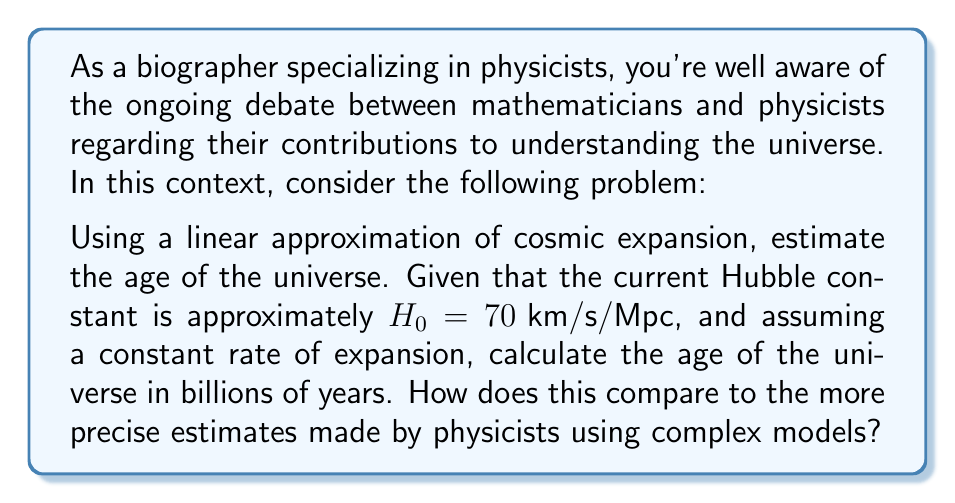Give your solution to this math problem. To solve this problem, we'll use a linear approximation of the Hubble-Lemaître law, which relates the recessional velocity of galaxies to their distance from Earth. This simplification allows us to estimate the age of the universe using basic mathematical concepts.

1. The Hubble-Lemaître law is given by:

   $v = H_0 \cdot d$

   where $v$ is the recessional velocity, $H_0$ is the Hubble constant, and $d$ is the distance.

2. If we assume a constant rate of expansion, we can use the simple relation:

   $\text{Time} = \frac{\text{Distance}}{\text{Velocity}}$

3. The age of the universe would be the time it takes for a galaxy to reach a distance of 1 from a starting point of 0, at the velocity given by the Hubble constant. Therefore:

   $\text{Age} = \frac{1}{H_0}$

4. Convert the Hubble constant to appropriate units:
   $H_0 = 70 \text{ km/s/Mpc} = 70 \frac{\text{km}}{\text{s} \cdot \text{Mpc}}$

   Convert this to $\text{s}^{-1}$:
   $70 \frac{\text{km}}{\text{s} \cdot \text{Mpc}} \cdot \frac{1 \text{ Mpc}}{3.086 \times 10^{19} \text{ km}} = 2.27 \times 10^{-18} \text{ s}^{-1}$

5. Calculate the age:
   $\text{Age} = \frac{1}{2.27 \times 10^{-18} \text{ s}^{-1}} = 4.41 \times 10^{17} \text{ s}$

6. Convert to billions of years:
   $4.41 \times 10^{17} \text{ s} \cdot \frac{1 \text{ year}}{3.156 \times 10^7 \text{ s}} \cdot \frac{1 \text{ billion}}{10^9} = 13.98 \text{ billion years}$

This linear approximation yields an estimate of about 14 billion years, which is surprisingly close to the more precise estimates made by physicists using complex models (around 13.8 billion years). However, it's important to note that this simple model doesn't account for the changing rate of expansion or the effects of dark energy, which physicists consider in their more advanced models.
Answer: The estimated age of the universe using a linear approximation of cosmic expansion is approximately 13.98 billion years. 